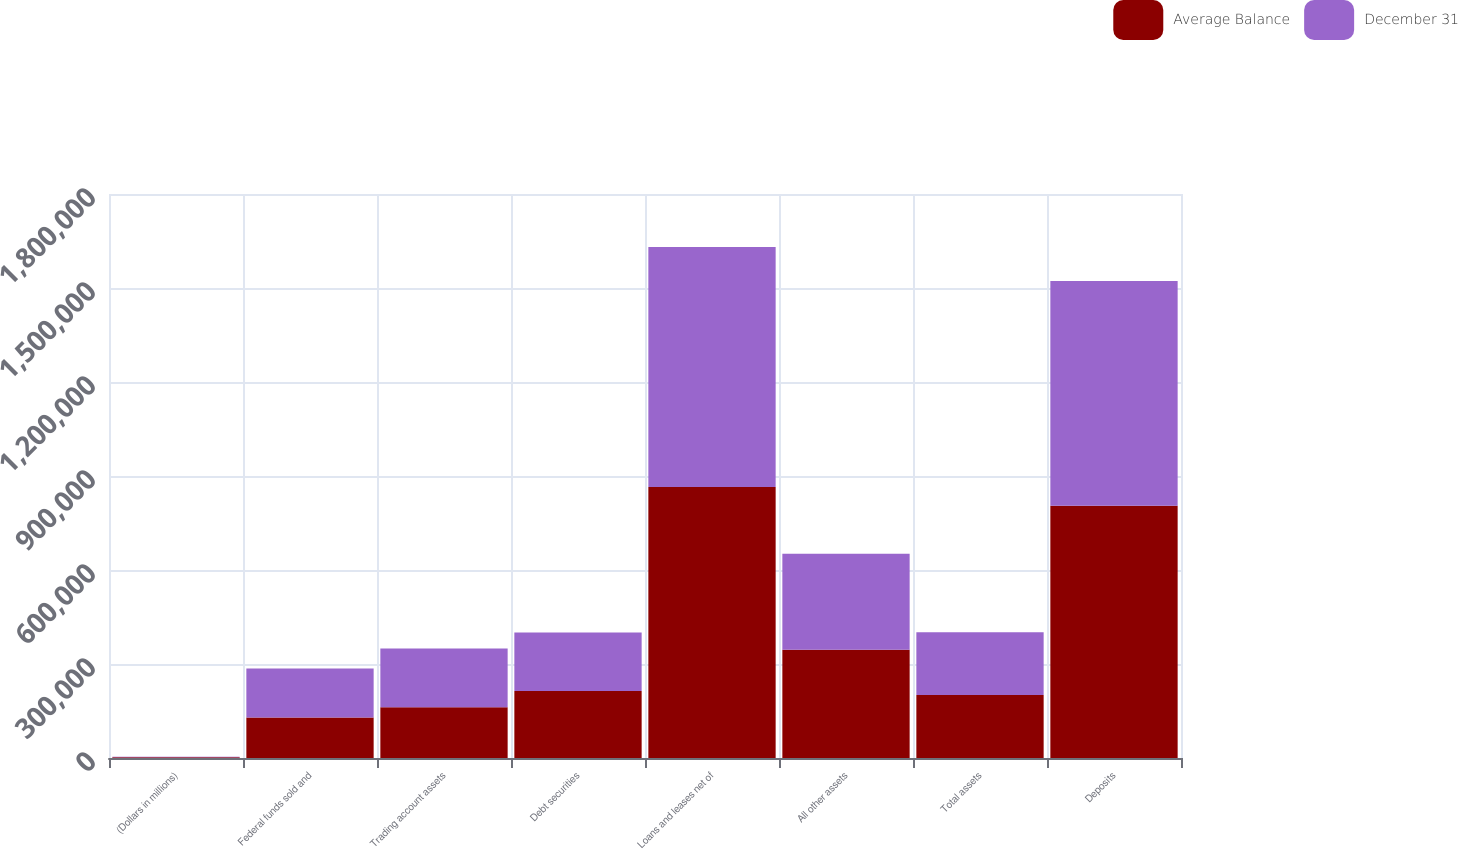<chart> <loc_0><loc_0><loc_500><loc_500><stacked_bar_chart><ecel><fcel>(Dollars in millions)<fcel>Federal funds sold and<fcel>Trading account assets<fcel>Debt securities<fcel>Loans and leases net of<fcel>All other assets<fcel>Total assets<fcel>Deposits<nl><fcel>Average Balance<fcel>2007<fcel>129552<fcel>162064<fcel>214056<fcel>864756<fcel>345318<fcel>200672<fcel>805177<nl><fcel>December 31<fcel>2007<fcel>155828<fcel>187287<fcel>186466<fcel>766329<fcel>306163<fcel>200672<fcel>717182<nl></chart> 